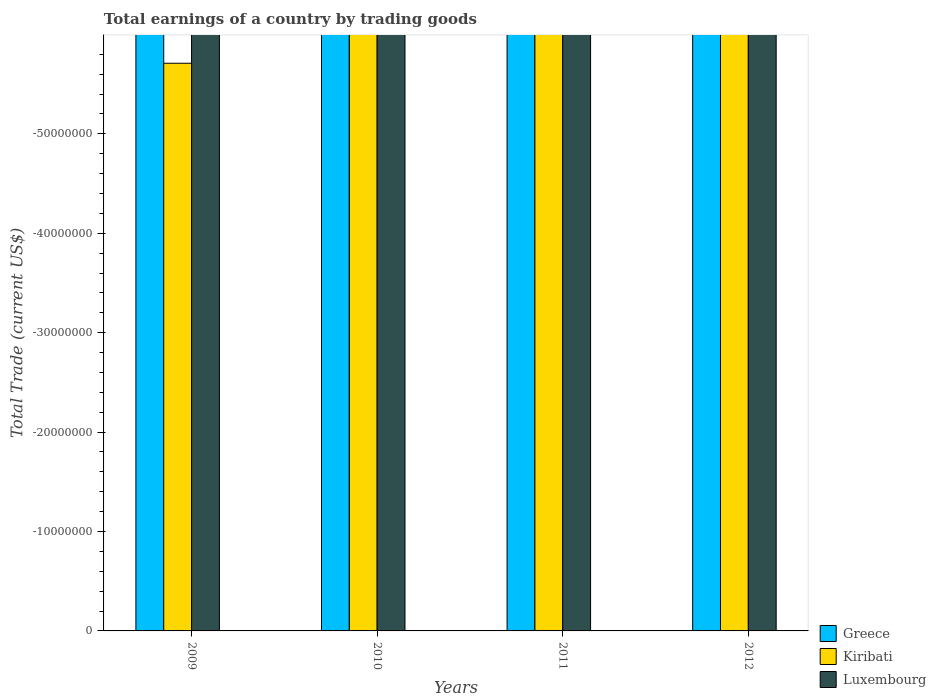Are the number of bars per tick equal to the number of legend labels?
Ensure brevity in your answer.  No. How many bars are there on the 1st tick from the left?
Offer a terse response. 0. How many bars are there on the 2nd tick from the right?
Offer a terse response. 0. What is the total earnings in Greece in 2010?
Make the answer very short. 0. Across all years, what is the minimum total earnings in Greece?
Provide a succinct answer. 0. What is the average total earnings in Greece per year?
Give a very brief answer. 0. How many bars are there?
Your answer should be very brief. 0. What is the difference between two consecutive major ticks on the Y-axis?
Offer a terse response. 1.00e+07. Does the graph contain grids?
Provide a succinct answer. No. How many legend labels are there?
Your response must be concise. 3. How are the legend labels stacked?
Offer a very short reply. Vertical. What is the title of the graph?
Provide a succinct answer. Total earnings of a country by trading goods. What is the label or title of the X-axis?
Provide a succinct answer. Years. What is the label or title of the Y-axis?
Provide a succinct answer. Total Trade (current US$). What is the Total Trade (current US$) of Luxembourg in 2009?
Make the answer very short. 0. What is the Total Trade (current US$) of Luxembourg in 2010?
Ensure brevity in your answer.  0. What is the Total Trade (current US$) of Luxembourg in 2011?
Ensure brevity in your answer.  0. What is the Total Trade (current US$) of Kiribati in 2012?
Offer a terse response. 0. What is the total Total Trade (current US$) in Kiribati in the graph?
Provide a short and direct response. 0. What is the average Total Trade (current US$) in Greece per year?
Provide a short and direct response. 0. What is the average Total Trade (current US$) of Kiribati per year?
Provide a short and direct response. 0. What is the average Total Trade (current US$) in Luxembourg per year?
Your response must be concise. 0. 